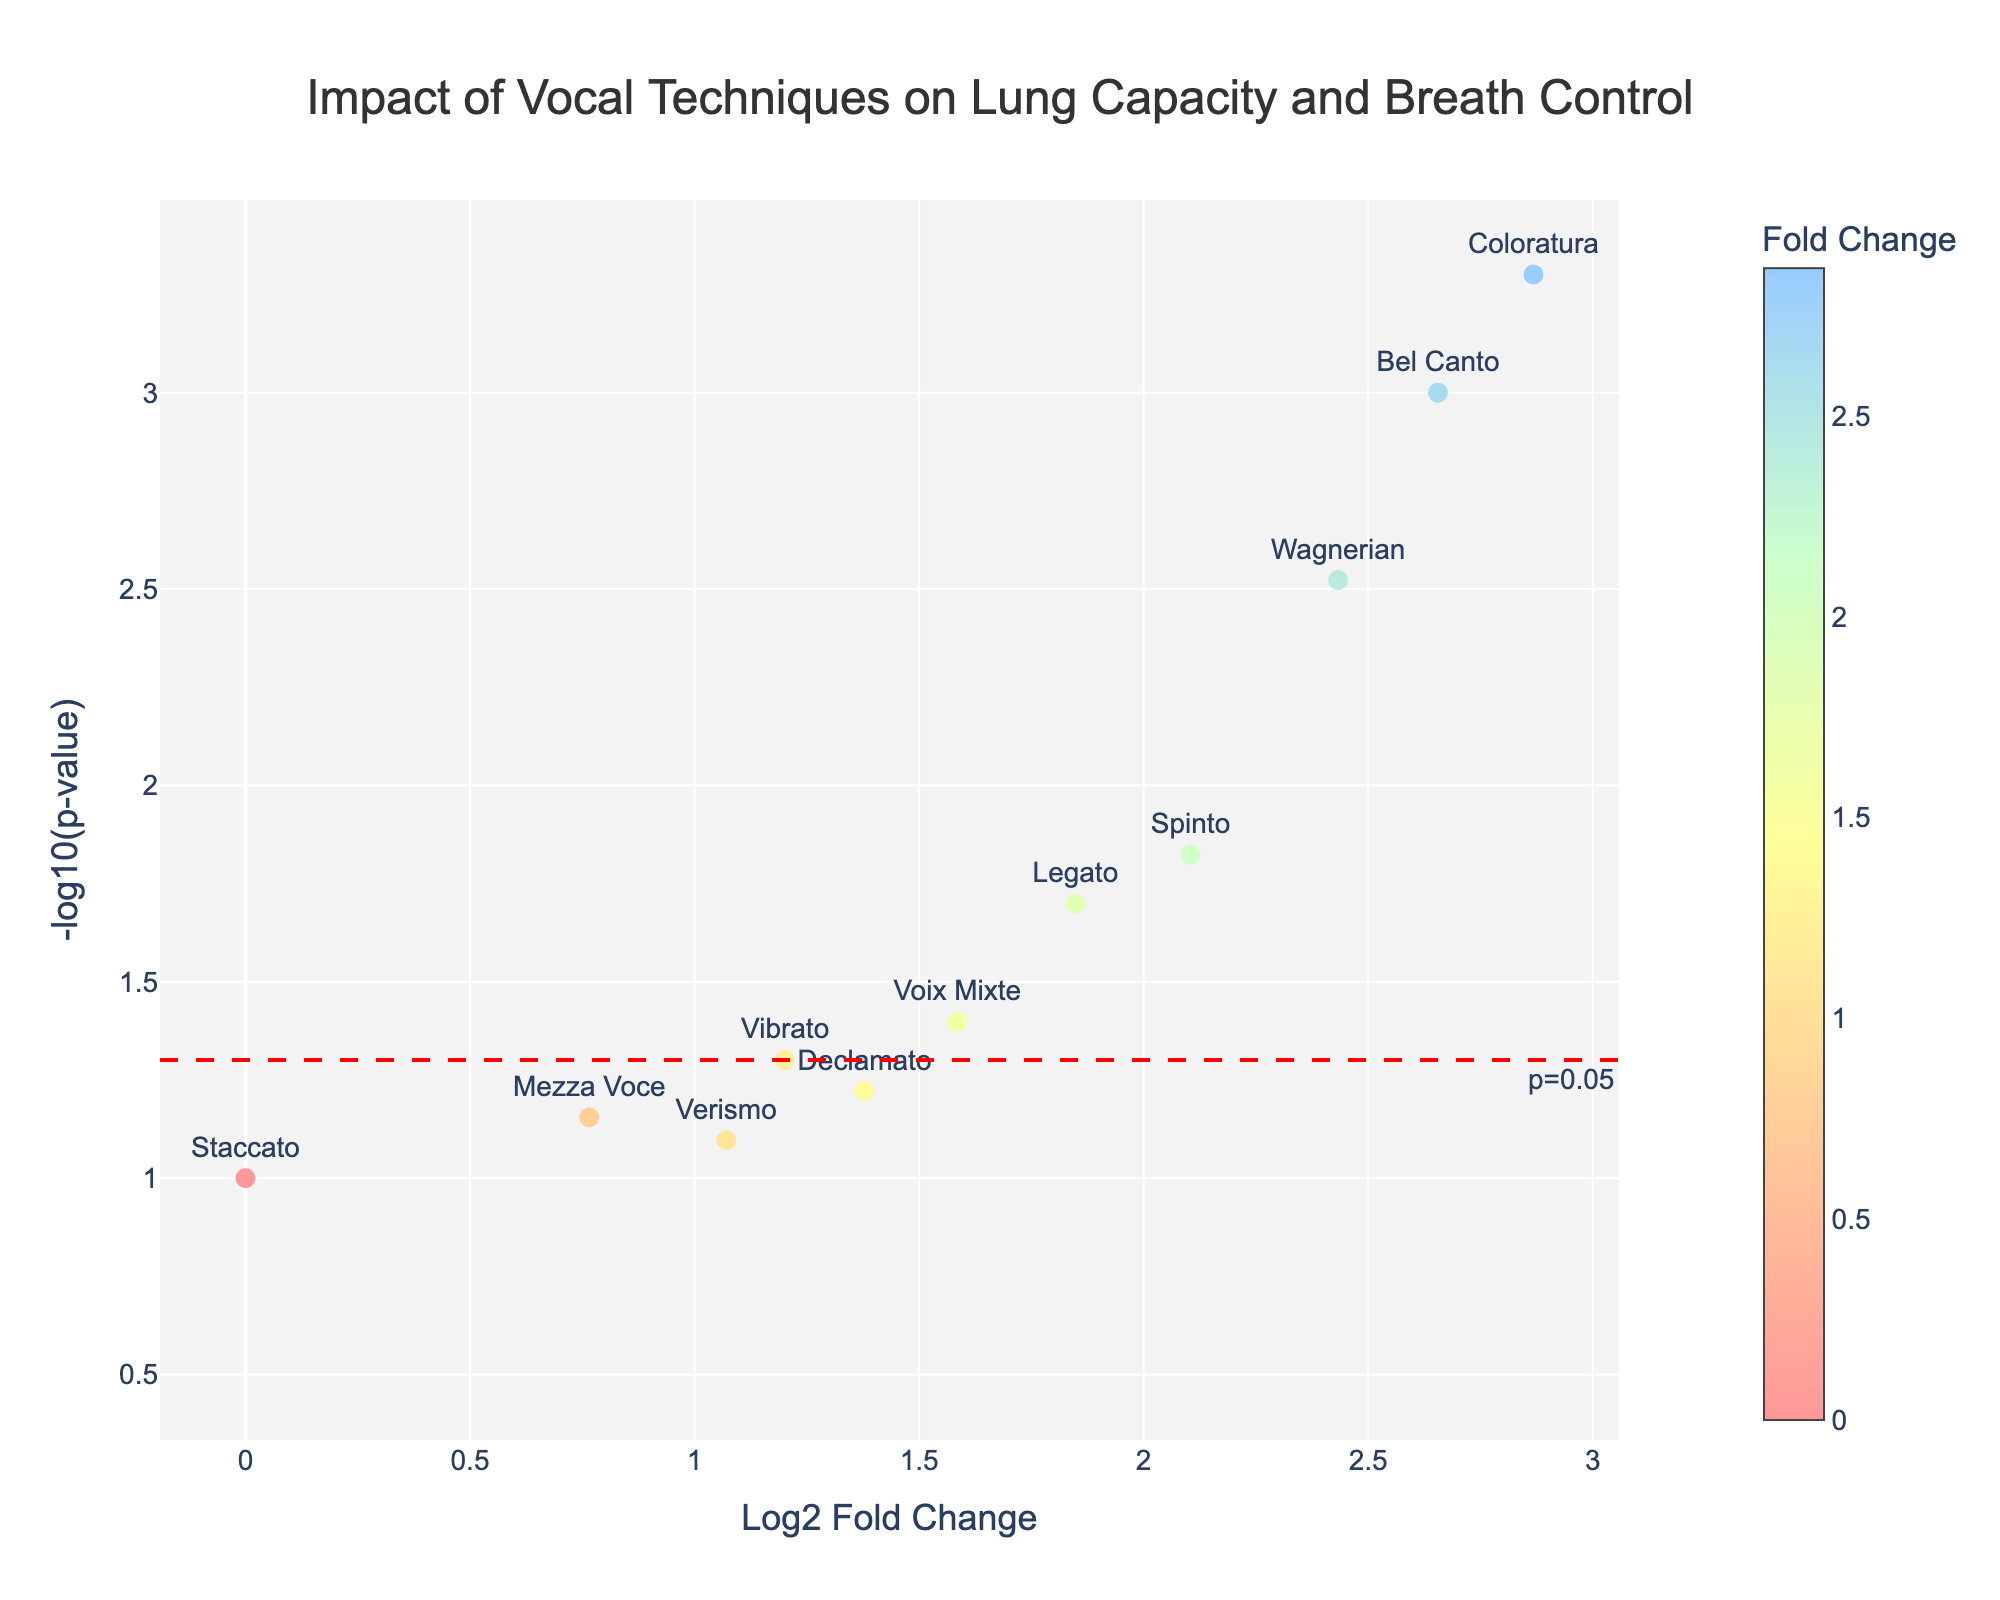How many vocal techniques were analyzed in the study? There are markers on the plot that represent each vocal technique. By counting these markers, you determine the number of techniques analyzed.
Answer: 13 What do the sizes of the markers on the plot represent? The assignment does not specify a varying marker size for this plot, which means all markers are likely to be the same size. Therefore, the sizes of the markers do not represent any variable in this plot.
Answer: They do not represent any variable Which vocal technique has the highest fold change? Examine the x-axis for the highest Log2 Fold Change value and match it with the corresponding marker's text label.
Answer: Coloratura Which technique is the least statistically significant and how do you know? Look for the data point with the lowest -log10(p-value) on the y-axis, and check the text label.
Answer: Parlando Are there any vocal techniques that result in a negative change in lung capacity or breath control? If so, name them. Identify any markers positioned along the negative side of the x-axis for Log2 Fold Change and match them to their text labels.
Answer: Falsetto, Parlando For which vocal techniques is the p-value less than 0.05? The techniques whose markers are above the horizontal red dashed line indicating p=0.05 on the y-axis are the ones with p < 0.05.
Answer: Bel Canto, Spinto, Coloratura, Wagnerian, Legato, Voix Mixte Which vocal technique is the closest to the significance cutoff of p=0.05? Locate the marker nearest to the horizontal red dashed line at -log10(p-value) of approximately 1.3 (where p=0.05) and check the text label.
Answer: Vibrato Which techniques have a fold change between 1 and 2? Look for markers on the x-axis (Log2 Fold Change) that fall between the values of 1 and 2 and match them to the corresponding text labels.
Answer: Spinto, Wagnerian, Legato, Voix Mixte Compare Bel Canto and Wagnerian techniques based on their lung capacity and breath control improvements. By referring to their relative positions on the x-axis, compare the Log2 Fold Change values associated with Bel Canto and Wagnerian, and discuss the differences.
Answer: Bel Canto has higher How many techniques have both a positive fold change and p-value less than 0.05? Count the markers that are both on the positive side of the x-axis and above the horizontal red dashed line on the y-axis for -log10(p-value).
Answer: 6 